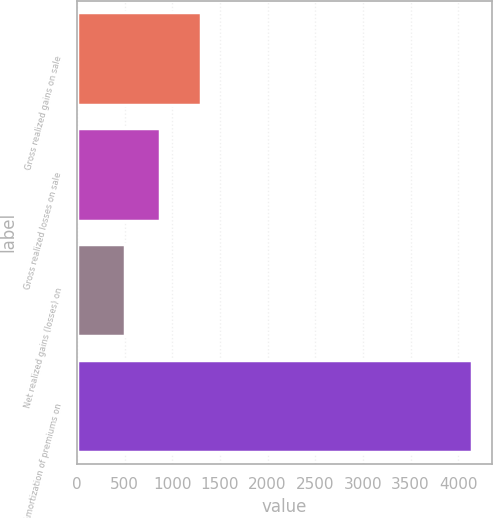<chart> <loc_0><loc_0><loc_500><loc_500><bar_chart><fcel>Gross realized gains on sale<fcel>Gross realized losses on sale<fcel>Net realized gains (losses) on<fcel>Amortization of premiums on<nl><fcel>1301<fcel>869.1<fcel>505<fcel>4146<nl></chart> 